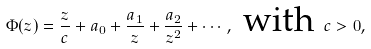<formula> <loc_0><loc_0><loc_500><loc_500>\Phi ( z ) = \frac { z } { c } + a _ { 0 } + \frac { a _ { 1 } } { z } + \frac { a _ { 2 } } { z ^ { 2 } } + \cdots , \text { with } c > 0 ,</formula> 